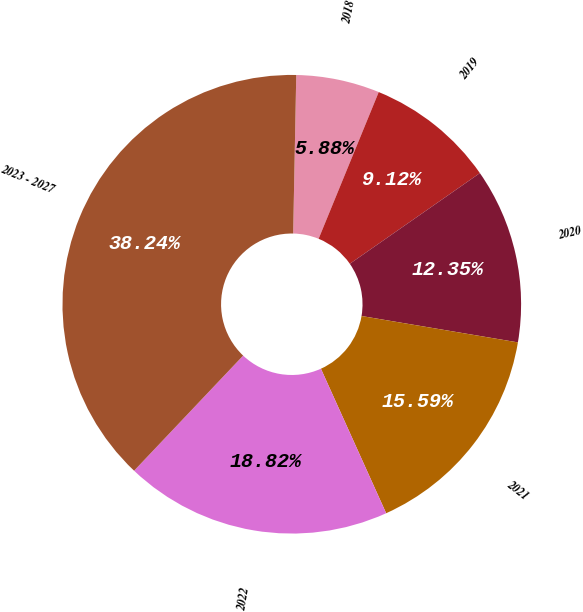<chart> <loc_0><loc_0><loc_500><loc_500><pie_chart><fcel>2018<fcel>2019<fcel>2020<fcel>2021<fcel>2022<fcel>2023 - 2027<nl><fcel>5.88%<fcel>9.12%<fcel>12.35%<fcel>15.59%<fcel>18.82%<fcel>38.24%<nl></chart> 